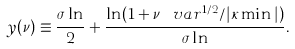Convert formula to latex. <formula><loc_0><loc_0><loc_500><loc_500>y ( \nu ) \equiv \frac { \sigma \ln } { 2 } + \frac { \ln ( 1 + \nu \, \ v a r ^ { 1 / 2 } / | \kappa \min | ) } { \sigma \ln } .</formula> 